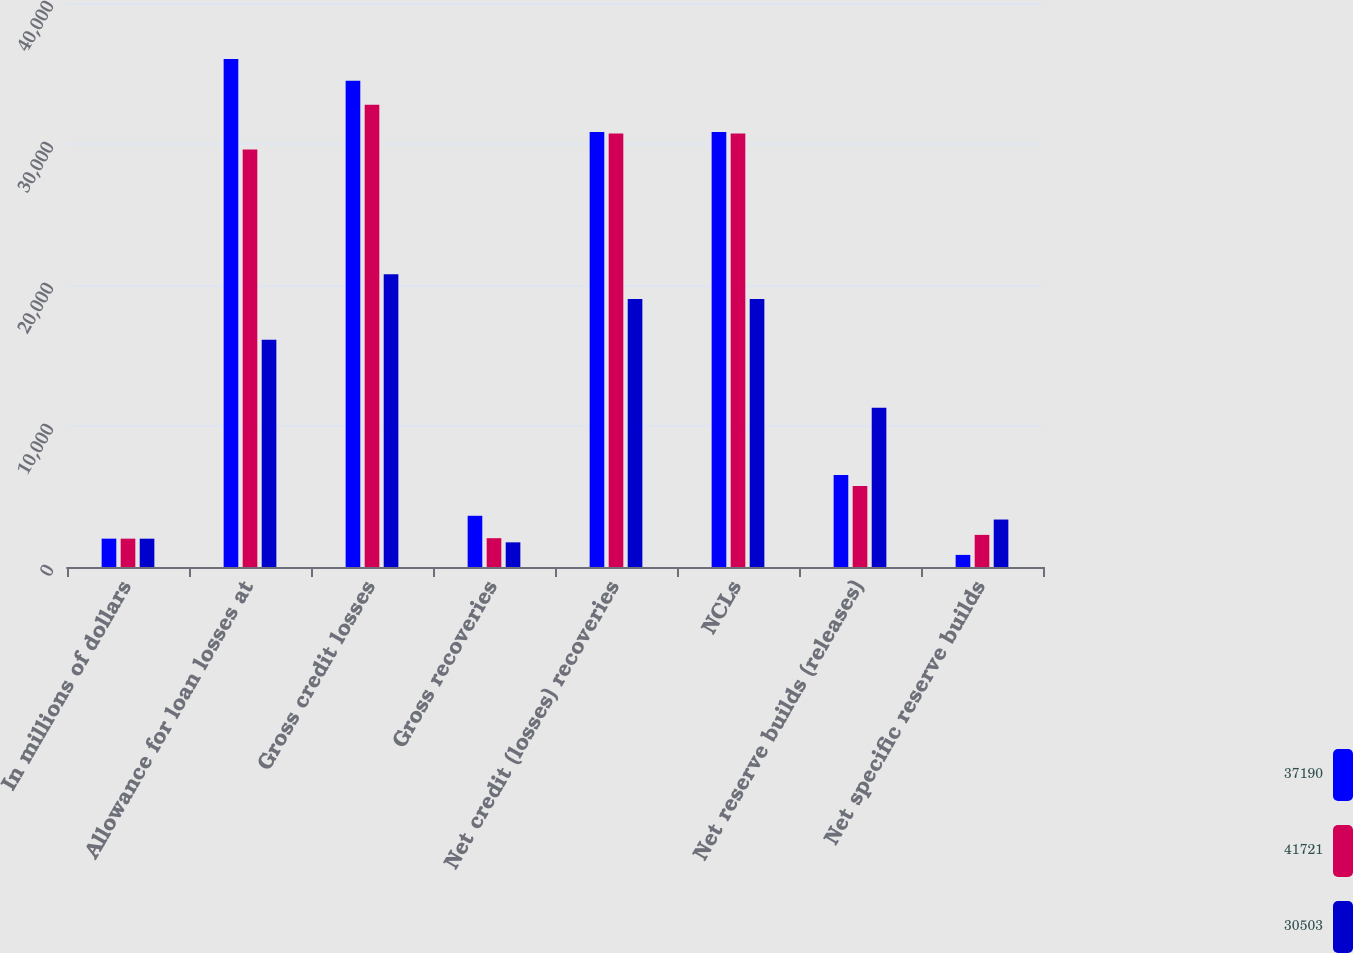<chart> <loc_0><loc_0><loc_500><loc_500><stacked_bar_chart><ecel><fcel>In millions of dollars<fcel>Allowance for loan losses at<fcel>Gross credit losses<fcel>Gross recoveries<fcel>Net credit (losses) recoveries<fcel>NCLs<fcel>Net reserve builds (releases)<fcel>Net specific reserve builds<nl><fcel>37190<fcel>2010<fcel>36033<fcel>34491<fcel>3632<fcel>30859<fcel>30859<fcel>6523<fcel>858<nl><fcel>41721<fcel>2009<fcel>29616<fcel>32784<fcel>2043<fcel>30741<fcel>30741<fcel>5741<fcel>2278<nl><fcel>30503<fcel>2008<fcel>16117<fcel>20760<fcel>1749<fcel>19011<fcel>19011<fcel>11297<fcel>3366<nl></chart> 